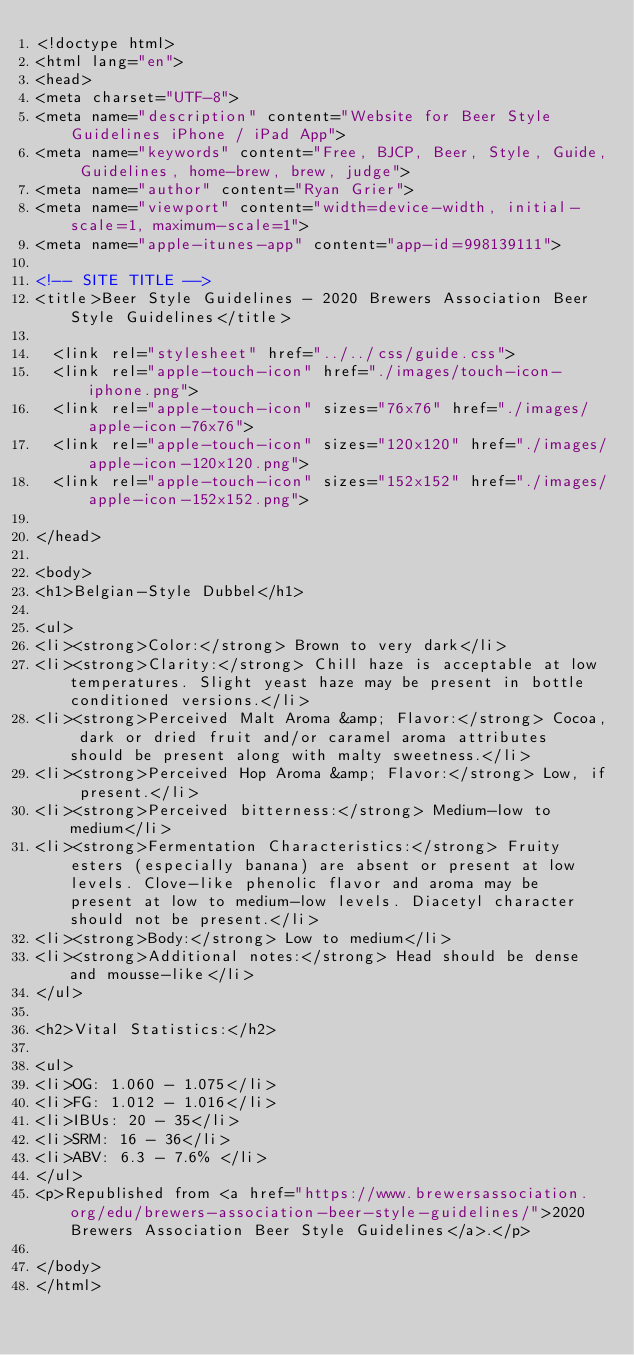Convert code to text. <code><loc_0><loc_0><loc_500><loc_500><_HTML_><!doctype html>
<html lang="en">
<head>
<meta charset="UTF-8">
<meta name="description" content="Website for Beer Style Guidelines iPhone / iPad App">
<meta name="keywords" content="Free, BJCP, Beer, Style, Guide, Guidelines, home-brew, brew, judge">
<meta name="author" content="Ryan Grier">
<meta name="viewport" content="width=device-width, initial-scale=1, maximum-scale=1">
<meta name="apple-itunes-app" content="app-id=998139111">

<!-- SITE TITLE -->
<title>Beer Style Guidelines - 2020 Brewers Association Beer Style Guidelines</title>

  <link rel="stylesheet" href="../../css/guide.css">
  <link rel="apple-touch-icon" href="./images/touch-icon-iphone.png">
  <link rel="apple-touch-icon" sizes="76x76" href="./images/apple-icon-76x76">
  <link rel="apple-touch-icon" sizes="120x120" href="./images/apple-icon-120x120.png">
  <link rel="apple-touch-icon" sizes="152x152" href="./images/apple-icon-152x152.png">

</head>

<body>
<h1>Belgian-Style Dubbel</h1>

<ul>
<li><strong>Color:</strong> Brown to very dark</li>
<li><strong>Clarity:</strong> Chill haze is acceptable at low temperatures. Slight yeast haze may be present in bottle conditioned versions.</li>
<li><strong>Perceived Malt Aroma &amp; Flavor:</strong> Cocoa, dark or dried fruit and/or caramel aroma attributes should be present along with malty sweetness.</li>
<li><strong>Perceived Hop Aroma &amp; Flavor:</strong> Low, if present.</li>
<li><strong>Perceived bitterness:</strong> Medium-low to medium</li>
<li><strong>Fermentation Characteristics:</strong> Fruity esters (especially banana) are absent or present at low levels. Clove-like phenolic flavor and aroma may be present at low to medium-low levels. Diacetyl character should not be present.</li>
<li><strong>Body:</strong> Low to medium</li>
<li><strong>Additional notes:</strong> Head should be dense and mousse-like</li>
</ul>

<h2>Vital Statistics:</h2>

<ul>
<li>OG: 1.060 - 1.075</li>
<li>FG: 1.012 - 1.016</li>
<li>IBUs: 20 - 35</li>
<li>SRM: 16 - 36</li>
<li>ABV: 6.3 - 7.6% </li>
</ul>
<p>Republished from <a href="https://www.brewersassociation.org/edu/brewers-association-beer-style-guidelines/">2020 Brewers Association Beer Style Guidelines</a>.</p>

</body>
</html>
</code> 